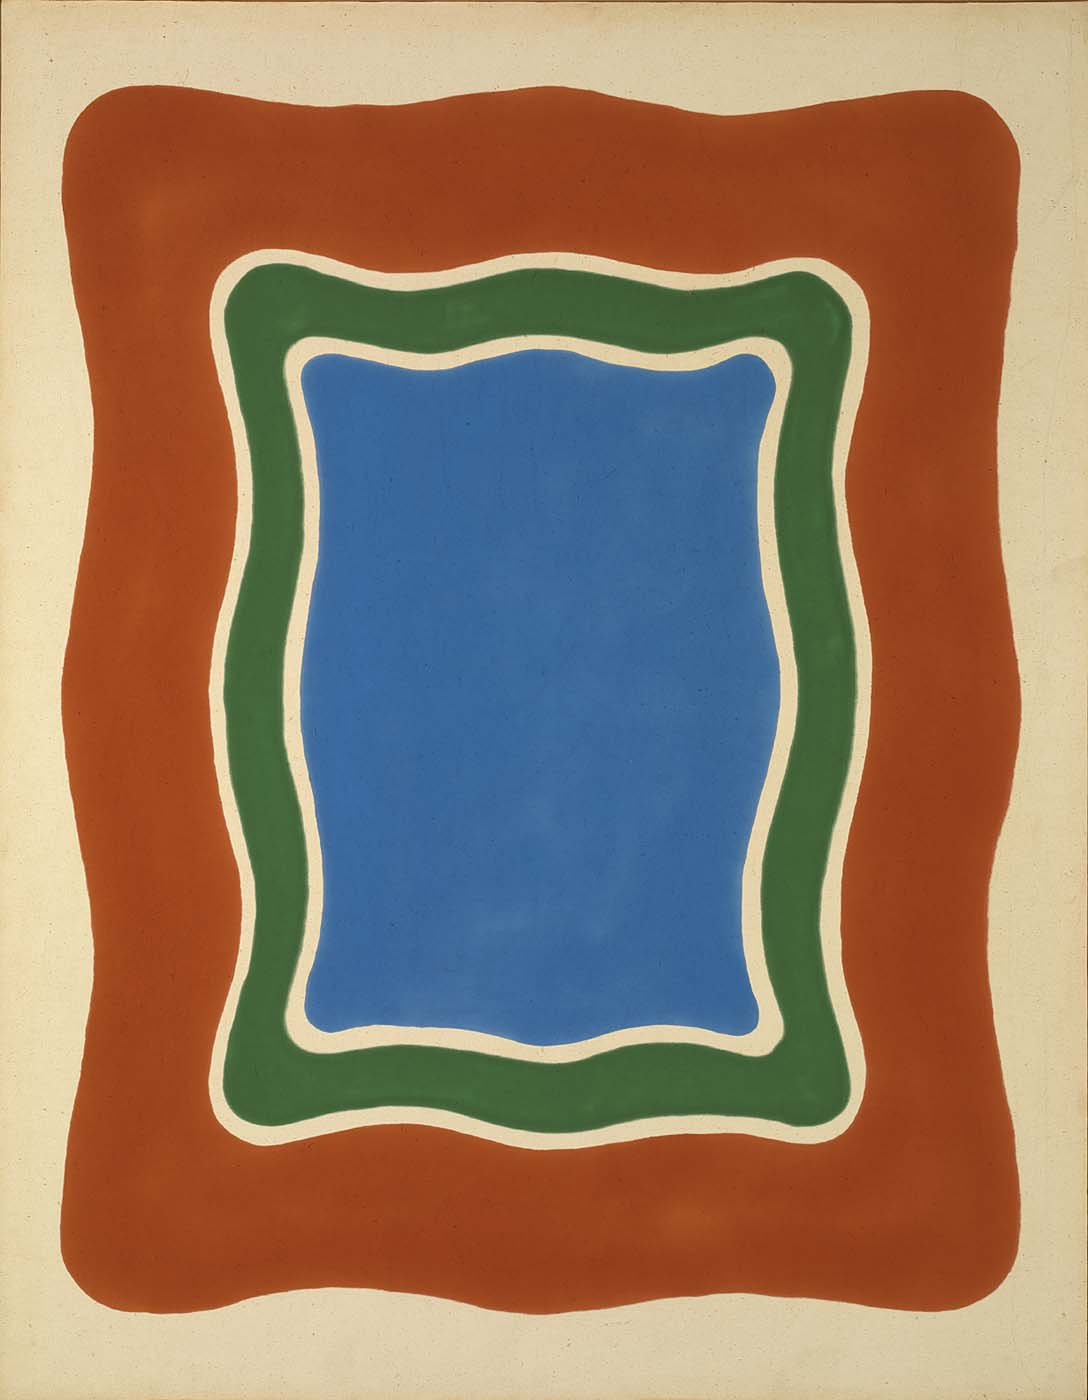Analyze the image in a comprehensive and detailed manner. The image is a captivating piece of modern abstract art. At its center, a bold blue rectangle commands attention, bordered by a vibrant green frame. This green border curves fluidly, creating a sense of movement, which contrasts with the more static blue form. Surrounding this dynamic duo is a thicker, deep red frame that adds a sense of completeness and stability to the composition. The art style is reminiscent of color field painting, focusing on large expanses of color and the emotional resonance they evoke. The background is a neutral off-white, allowing the colorful forms to stand out starkly, emphasizing their vibrancy. This sophisticated interplay of primary colors - blue, green, and red - along with the fluid lines and shapes, generates depth and complexity, stimulating the viewer’s imagination and emotions. 